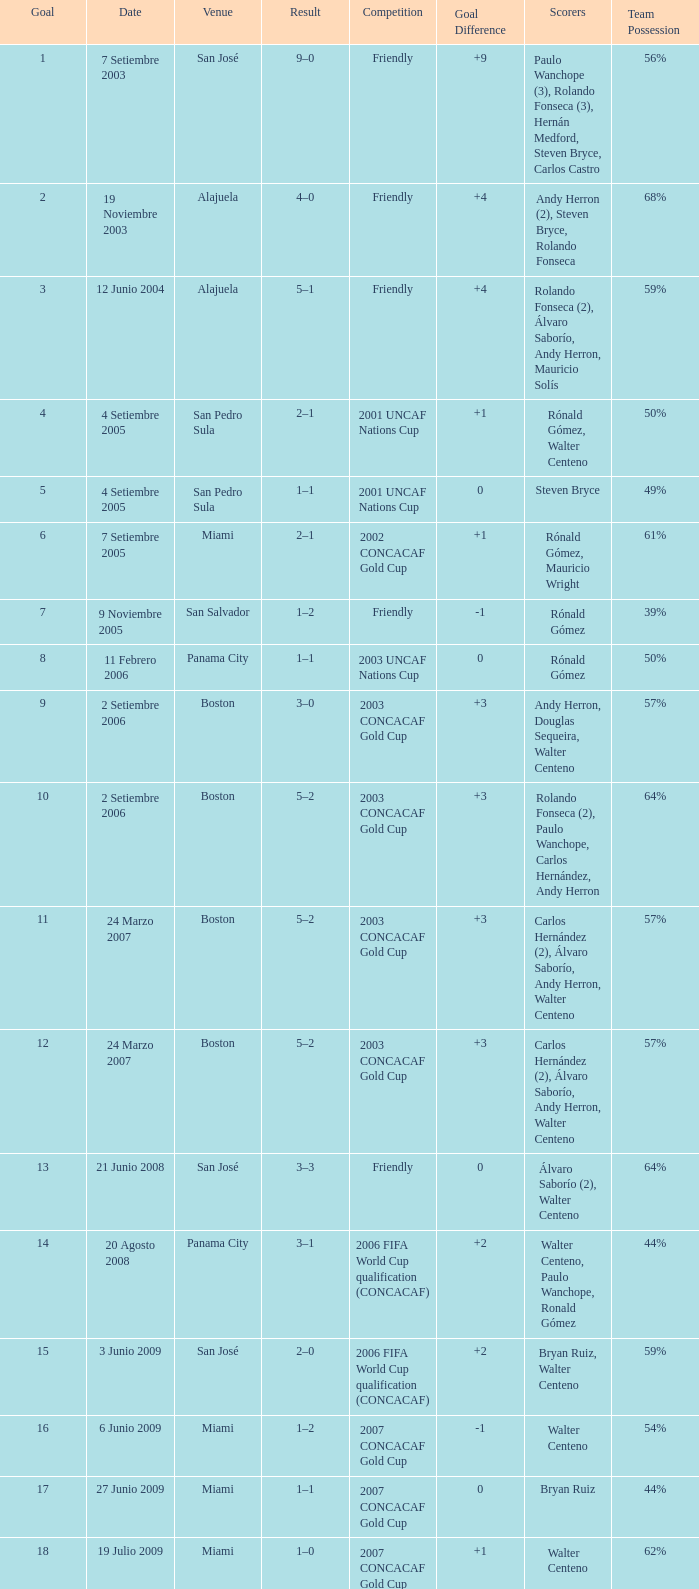How many goals were scored on 21 Junio 2008? 1.0. 